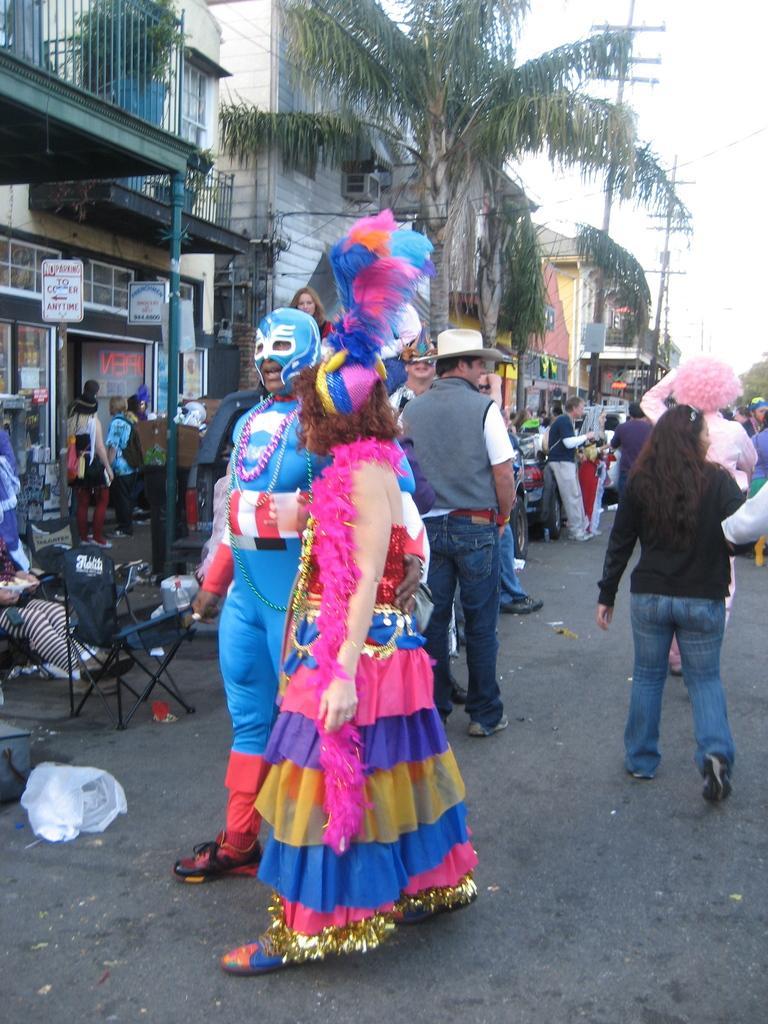Please provide a concise description of this image. In this image we can see two people wearing costumes. There are people walking on the road. To the left side of the image there are buildings, trees. In the background of the image there are electric poles, sky. At the bottom of the image there is road. 